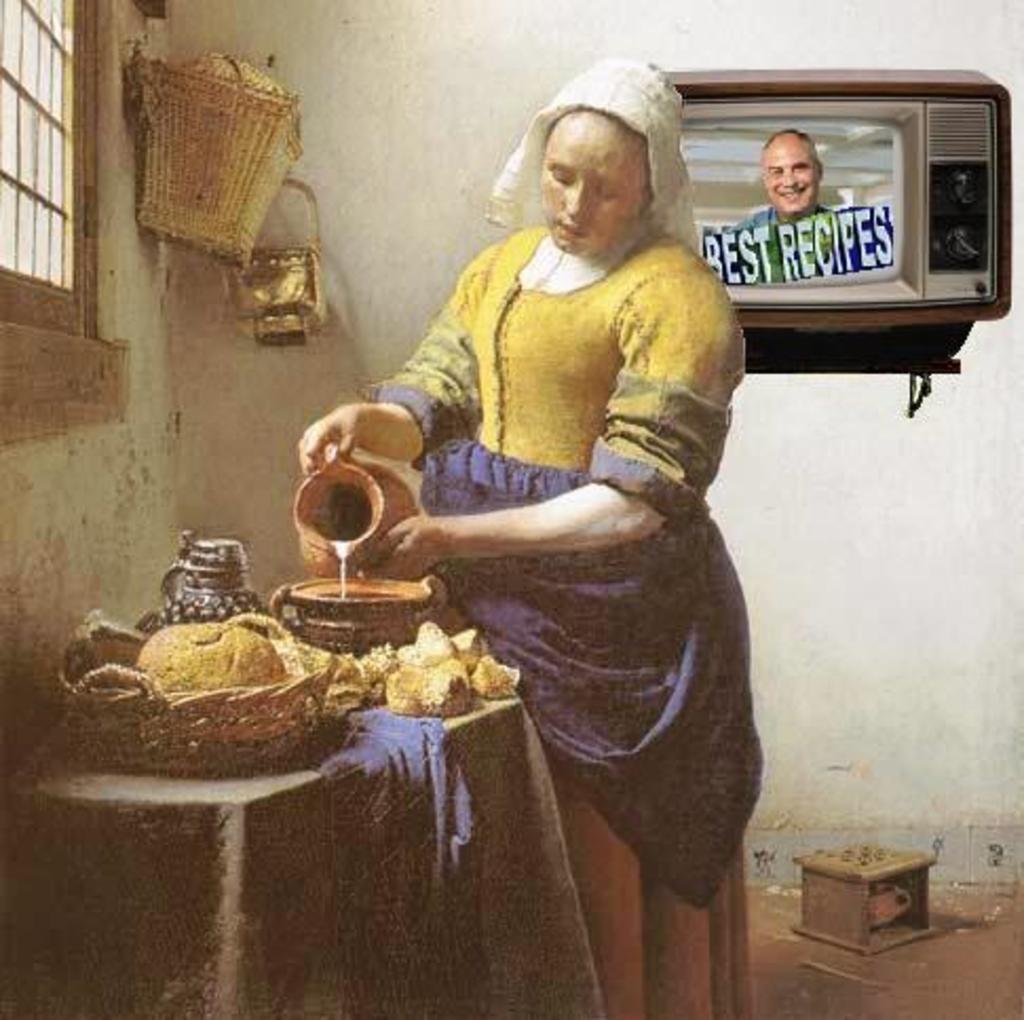Describe this image in one or two sentences. This is an edited picture of a woman standing holding a jug. We can also see a basket and some objects placed on a table, a box on the floor, some baskets on a wall, a window and a television. 